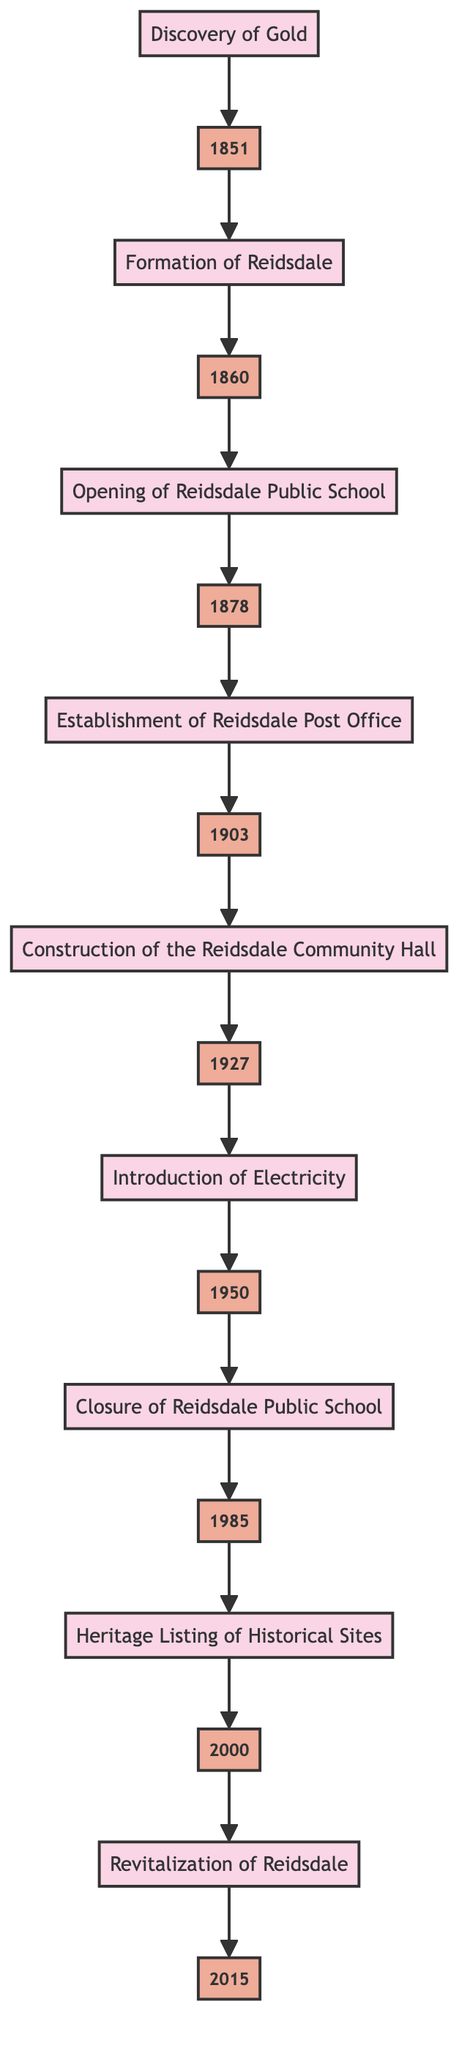What year marks the discovery of gold in Reidsdale? The flowchart indicates that the event "Discovery of Gold" occurred in the year 1851, which is the first event displayed at the bottom of the diagram.
Answer: 1851 What is the last event shown in the flowchart? The final event in the flowchart, located at the top, is "Revitalization of Reidsdale," which indicates ongoing efforts in the community.
Answer: Revitalization of Reidsdale How many significant events are listed in the flowchart? By counting the nodes in the flowchart, there are a total of 9 significant events represented, spanning from 1851 to 2015.
Answer: 9 Which year corresponds with the introduction of electricity to Reidsdale? The flowchart shows that the event "Introduction of Electricity" corresponds with the year 1950, as it is the node before the event "Closure of Reidsdale Public School."
Answer: 1950 What major change occurred in Reidsdale in 1985? According to the flowchart, the event that took place in 1985 is the "Closure of Reidsdale Public School," marking a significant change in local education.
Answer: Closure of Reidsdale Public School What event directly followed the establishment of the Reidsdale Post Office? The event that follows "Establishment of Reidsdale Post Office," which occurred in 1903, is "Construction of the Reidsdale Community Hall," noted in 1927 within the flowchart.
Answer: Construction of the Reidsdale Community Hall Which two events occurred in the 1900s? The flowchart indicates two events in the 1900s: “Establishment of Reidsdale Post Office” in 1903 and “Introduction of Electricity” in 1950.
Answer: Establishment of Reidsdale Post Office, Introduction of Electricity What was the first event to occur in Reidsdale's history? The first event shown in the flowchart is "Discovery of Gold" in 1851, which signifies the beginning of significant historical events in the area.
Answer: Discovery of Gold How are the events organized in the flowchart? The events in the flowchart are organized in a chronological order, flowing from the earliest event at the bottom (1851) to the most recent event at the top (2015).
Answer: Chronological order 